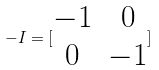Convert formula to latex. <formula><loc_0><loc_0><loc_500><loc_500>- I = [ \begin{matrix} - 1 & 0 \\ 0 & - 1 \end{matrix} ]</formula> 